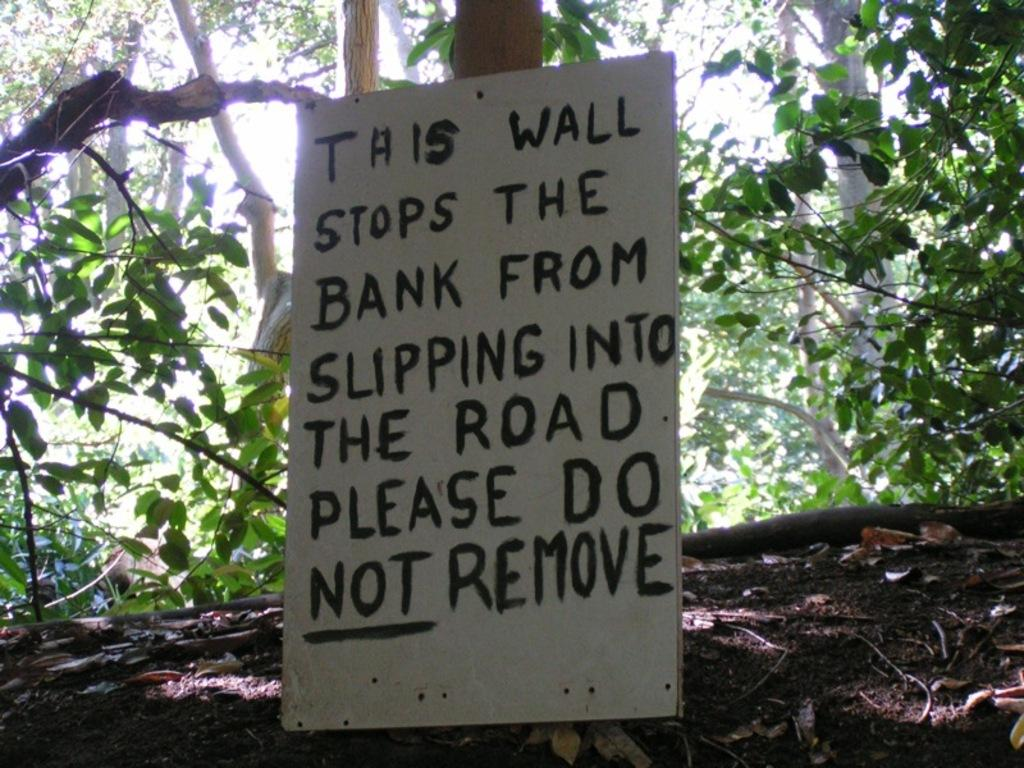What is the main object in the center of the image? There is a cardboard in the center of the image. What is written on the cardboard? There is text written on the cardboard. What can be seen in the background of the image? There are trees and the sky visible in the background of the image. What is your aunt doing while reading and hating in the image? There is no mention of an aunt, reading, or hate in the image. The image only features a cardboard with text and a background with trees and the sky. 